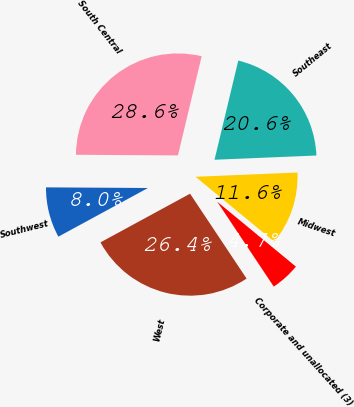<chart> <loc_0><loc_0><loc_500><loc_500><pie_chart><fcel>Midwest<fcel>Southeast<fcel>South Central<fcel>Southwest<fcel>West<fcel>Corporate and unallocated (3)<nl><fcel>11.64%<fcel>20.6%<fcel>28.64%<fcel>8.02%<fcel>26.43%<fcel>4.67%<nl></chart> 